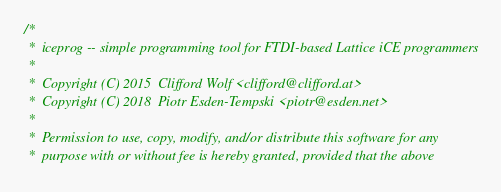Convert code to text. <code><loc_0><loc_0><loc_500><loc_500><_C_>/*
 *  iceprog -- simple programming tool for FTDI-based Lattice iCE programmers
 *
 *  Copyright (C) 2015  Clifford Wolf <clifford@clifford.at>
 *  Copyright (C) 2018  Piotr Esden-Tempski <piotr@esden.net>
 *
 *  Permission to use, copy, modify, and/or distribute this software for any
 *  purpose with or without fee is hereby granted, provided that the above</code> 